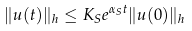<formula> <loc_0><loc_0><loc_500><loc_500>\| u ( t ) \| _ { h } \leq K _ { S } e ^ { \alpha _ { S } t } \| u ( 0 ) \| _ { h }</formula> 